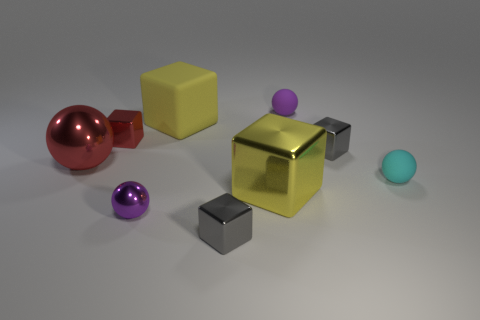Is there anything else that has the same material as the small cyan object?
Offer a terse response. Yes. The big ball is what color?
Offer a very short reply. Red. Do the big shiny sphere and the matte cube have the same color?
Your answer should be compact. No. What number of gray blocks are left of the gray metal thing that is behind the cyan object?
Your answer should be very brief. 1. There is a matte thing that is both behind the tiny red shiny thing and in front of the purple rubber thing; what size is it?
Your response must be concise. Large. What is the material of the big red ball to the left of the cyan sphere?
Provide a succinct answer. Metal. Are there any cyan rubber objects that have the same shape as the large red metal thing?
Provide a short and direct response. Yes. How many small metal things have the same shape as the yellow rubber thing?
Your answer should be compact. 3. Do the sphere that is behind the large red thing and the yellow thing behind the cyan thing have the same size?
Keep it short and to the point. No. What shape is the big thing to the left of the red cube that is to the left of the large rubber thing?
Your answer should be very brief. Sphere. 